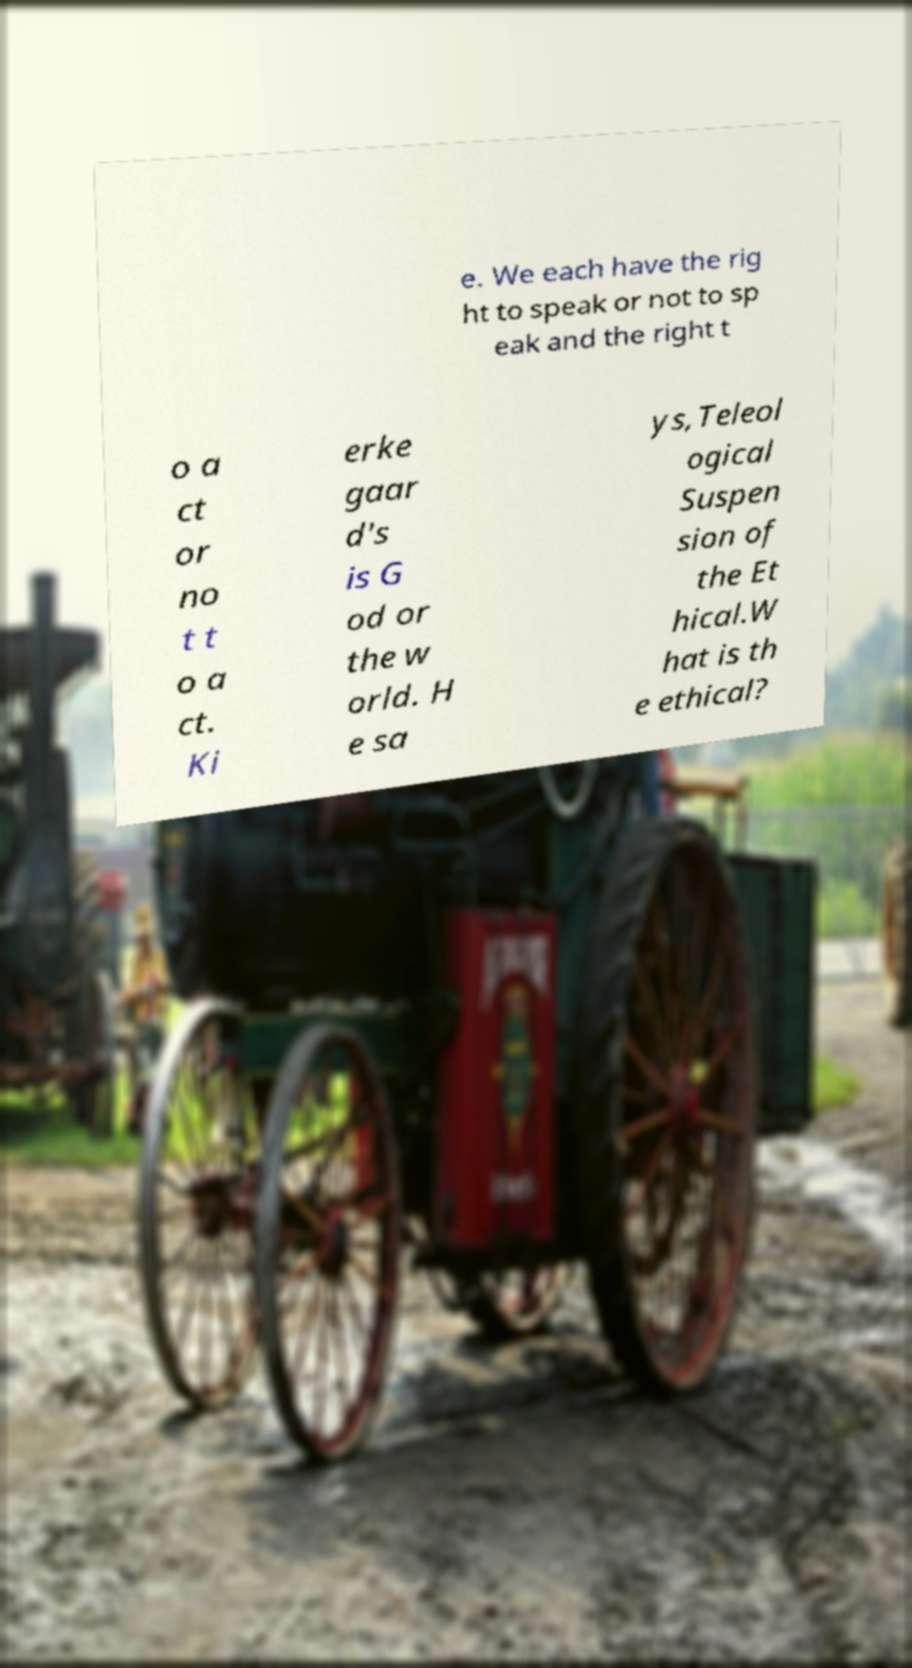Can you read and provide the text displayed in the image?This photo seems to have some interesting text. Can you extract and type it out for me? e. We each have the rig ht to speak or not to sp eak and the right t o a ct or no t t o a ct. Ki erke gaar d's is G od or the w orld. H e sa ys,Teleol ogical Suspen sion of the Et hical.W hat is th e ethical? 